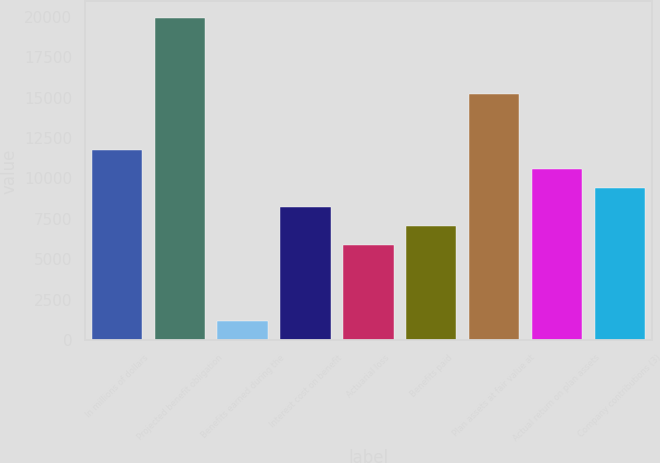<chart> <loc_0><loc_0><loc_500><loc_500><bar_chart><fcel>In millions of dollars<fcel>Projected benefit obligation<fcel>Benefits earned during the<fcel>Interest cost on benefit<fcel>Actuarial loss<fcel>Benefits paid<fcel>Plan assets at fair value at<fcel>Actual return on plan assets<fcel>Company contributions (3)<nl><fcel>11730<fcel>19940.3<fcel>1173.9<fcel>8211.3<fcel>5865.5<fcel>7038.4<fcel>15248.7<fcel>10557.1<fcel>9384.2<nl></chart> 